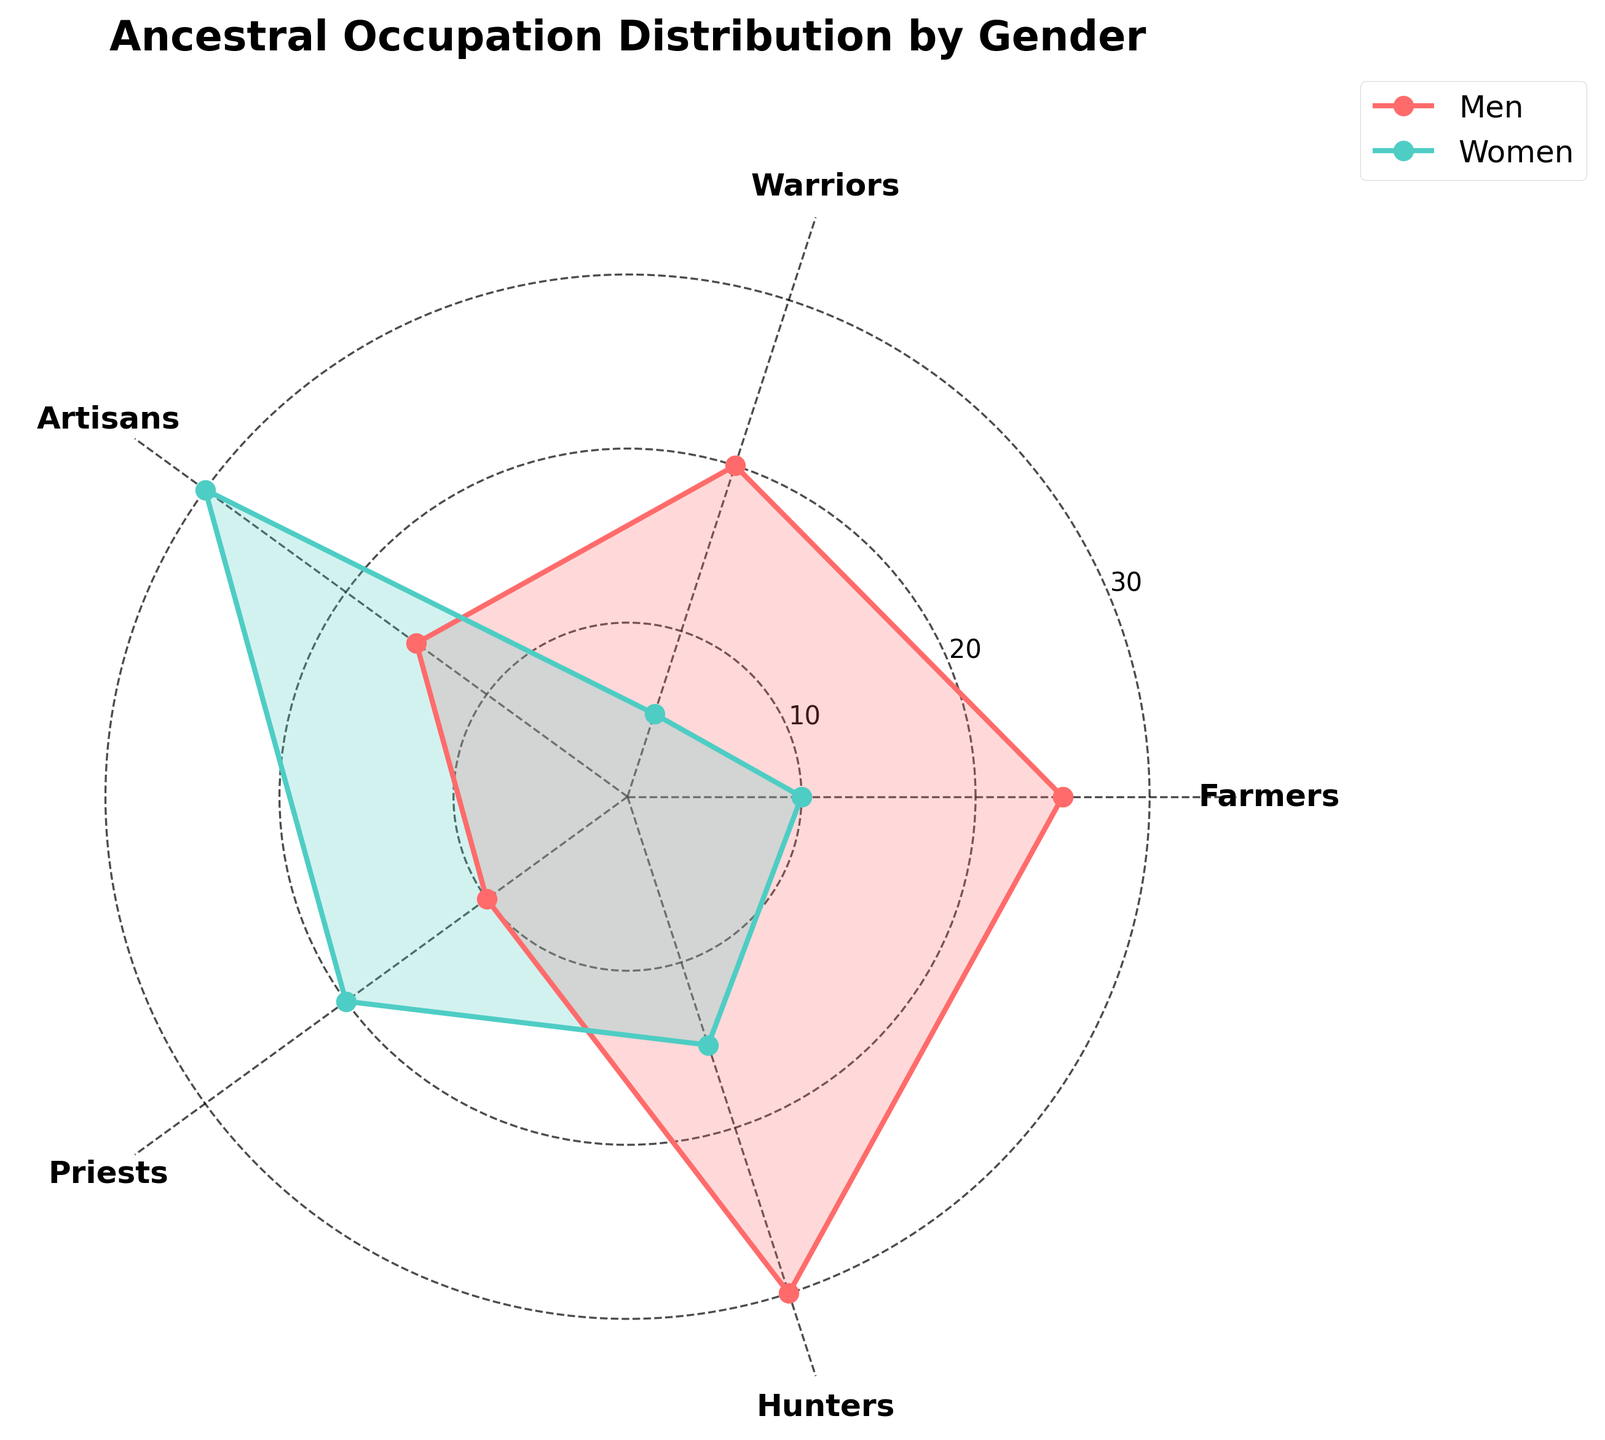What is the occupation with the highest representation for men? By looking at the radar chart, we can see that the men’s category has the highest value at the 'Hunters' occupation.
Answer: Hunters How many ticks are along the radial axis? The radial axis has ticks marked at 10, 20, and 30.
Answer: 3 Which occupation has the lowest women representation? The radar chart shows that the lowest value for women is at the 'Warriors' occupation.
Answer: Warriors What is the sum of the values for men in the 'Farmers' and 'Warriors' occupations? The values for men in 'Farmers' and 'Warriors' occupations are 25 and 20, respectively. The sum is 25 + 20 = 45.
Answer: 45 Which gender has a higher representation in the 'Artisans' occupation? The radar chart shows that the value for women in 'Artisans' occupation is 30, whereas for men, it's 15. Hence, women have a higher representation.
Answer: Women Is there any occupation where women have a higher representation than men? If yes, name it. By comparing the values in each occupation, we see that women have a higher representation in the 'Artisans' and 'Priests' occupations.
Answer: Artisans, Priests What's the average number of men across all occupations? The values for men in all occupations are 25, 20, 15, 10, and 30. The sum is 25 + 20 + 15 + 10 + 30 = 100. There are 5 occupations, so the average is 100 / 5 = 20.
Answer: 20 Which two occupations have equal representation for women? By examining the chart, it is visible that 'Farmers' and 'Hunters' both have women representation of 15.
Answer: Farmers, Hunters What is the difference in the number of men and women in the 'Hunters' occupation? The value for men in the 'Hunters' occupation is 30 and for women, it's 15. The difference is 30 - 15 = 15.
Answer: 15 Which occupation shows the smallest difference between the number of men and women? By comparing the differences in all occupations, we find that the smallest difference is in the 'Priests' occupation, where the difference is 10 - 20 = -10 (or 10 in absolute terms).
Answer: Priests 